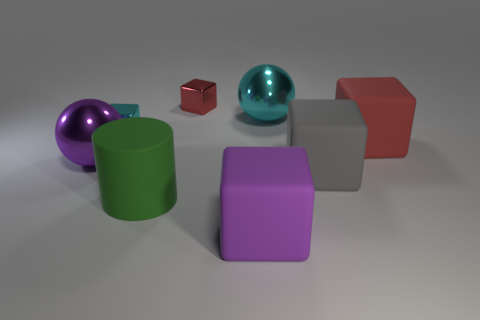What shape is the large shiny thing behind the big sphere left of the metallic sphere that is behind the small cyan object?
Your answer should be very brief. Sphere. Does the large red matte object have the same shape as the green matte object?
Make the answer very short. No. The large gray object to the right of the cyan shiny object that is on the right side of the small cyan block is what shape?
Make the answer very short. Cube. Is there a big green thing?
Keep it short and to the point. Yes. What number of large gray matte cubes are in front of the red block that is on the right side of the rubber block that is in front of the large green matte thing?
Your answer should be very brief. 1. There is a big gray rubber thing; does it have the same shape as the big metallic object to the right of the tiny red thing?
Your response must be concise. No. Are there more large purple things than purple rubber objects?
Offer a terse response. Yes. Do the purple object right of the purple shiny object and the small red object have the same shape?
Offer a very short reply. Yes. Is the number of matte blocks in front of the big red thing greater than the number of cyan spheres?
Give a very brief answer. Yes. What is the color of the large ball to the right of the large purple thing that is in front of the purple shiny object?
Ensure brevity in your answer.  Cyan. 